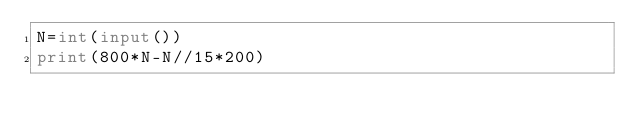Convert code to text. <code><loc_0><loc_0><loc_500><loc_500><_Python_>N=int(input())
print(800*N-N//15*200)
</code> 